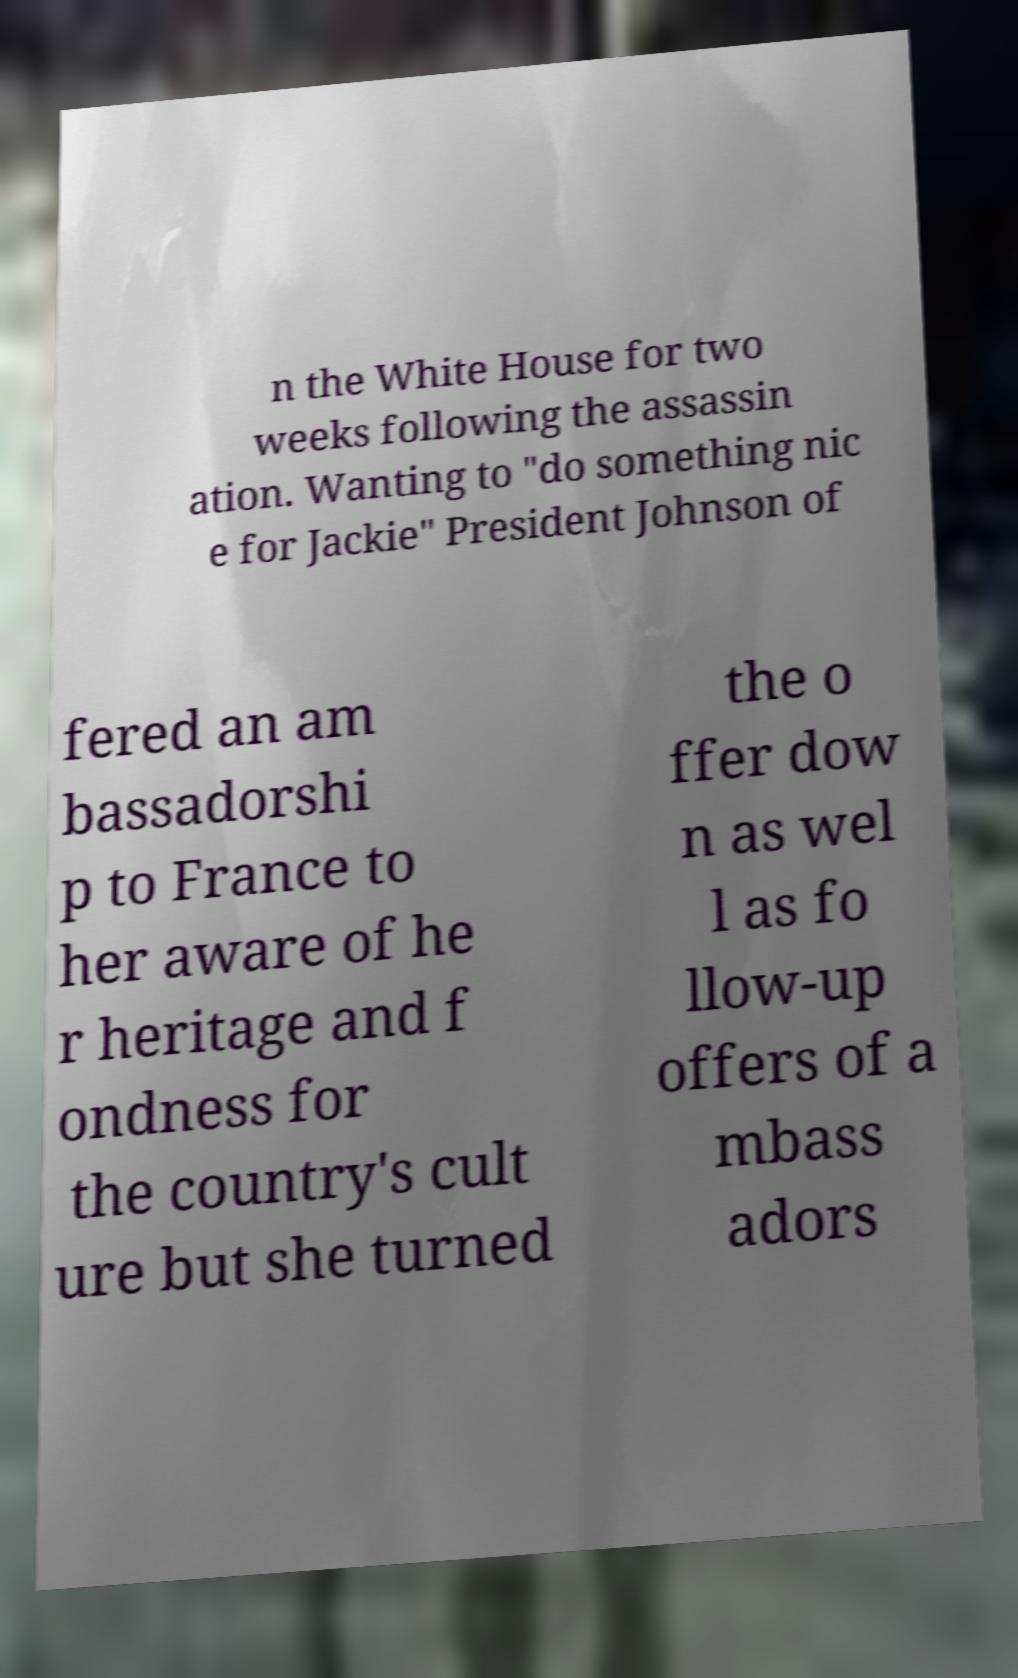Could you extract and type out the text from this image? n the White House for two weeks following the assassin ation. Wanting to "do something nic e for Jackie" President Johnson of fered an am bassadorshi p to France to her aware of he r heritage and f ondness for the country's cult ure but she turned the o ffer dow n as wel l as fo llow-up offers of a mbass adors 